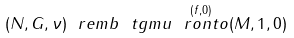<formula> <loc_0><loc_0><loc_500><loc_500>( N , G , \nu ) \ r e m b \ t g m u \overset { ( f , 0 ) } { \ r o n t o } ( M , 1 , 0 )</formula> 